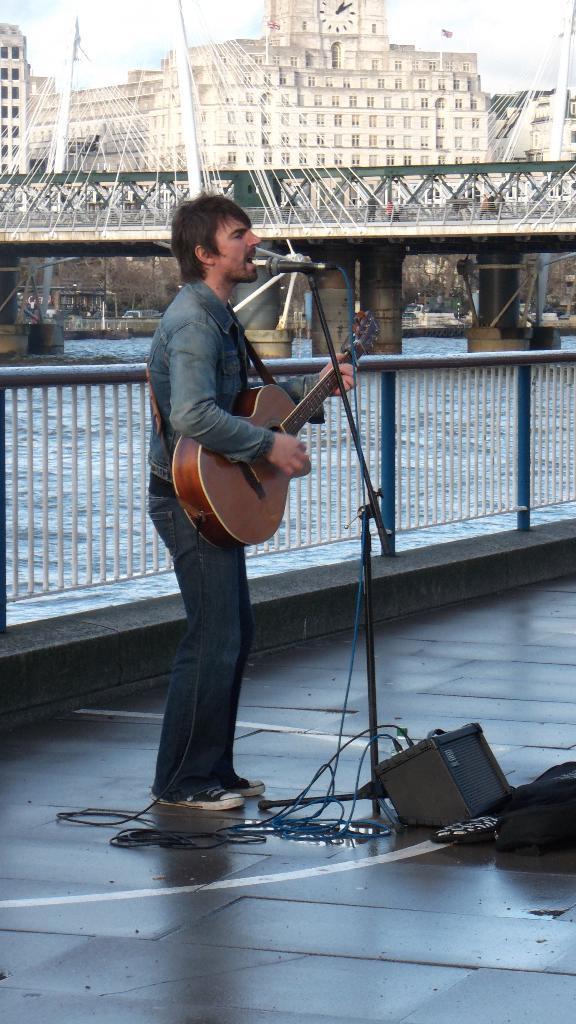Please provide a concise description of this image. There is a man standing on the floor playing a musical instrument through microphone which is connected to the sound box which is placed on the floor and at the backside of the man there is a fencing and at the top of the image there is a bridge and a wall which has a wall clock. 